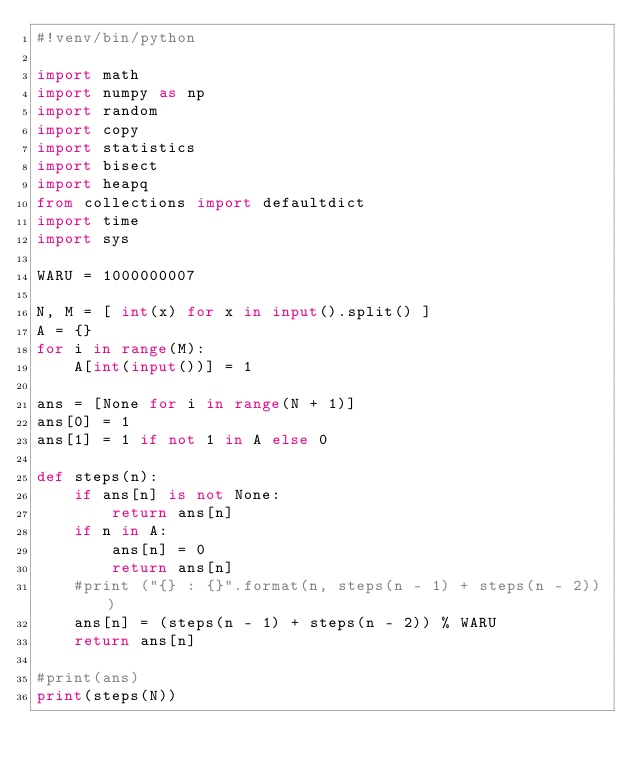<code> <loc_0><loc_0><loc_500><loc_500><_Python_>#!venv/bin/python
 
import math
import numpy as np
import random
import copy
import statistics 
import bisect
import heapq
from collections import defaultdict 
import time
import sys

WARU = 1000000007

N, M = [ int(x) for x in input().split() ]
A = {}
for i in range(M):
    A[int(input())] = 1

ans = [None for i in range(N + 1)]
ans[0] = 1
ans[1] = 1 if not 1 in A else 0

def steps(n):
    if ans[n] is not None:
        return ans[n]
    if n in A:
        ans[n] = 0
        return ans[n]
    #print ("{} : {}".format(n, steps(n - 1) + steps(n - 2)))
    ans[n] = (steps(n - 1) + steps(n - 2)) % WARU
    return ans[n]

#print(ans)
print(steps(N))
</code> 